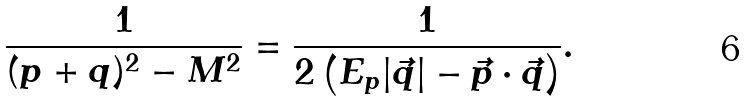Convert formula to latex. <formula><loc_0><loc_0><loc_500><loc_500>\frac { 1 } { ( p + q ) ^ { 2 } - M ^ { 2 } } = \frac { 1 } { 2 \left ( E _ { p } | \vec { q } | - \vec { p } \cdot \vec { q } \right ) } .</formula> 